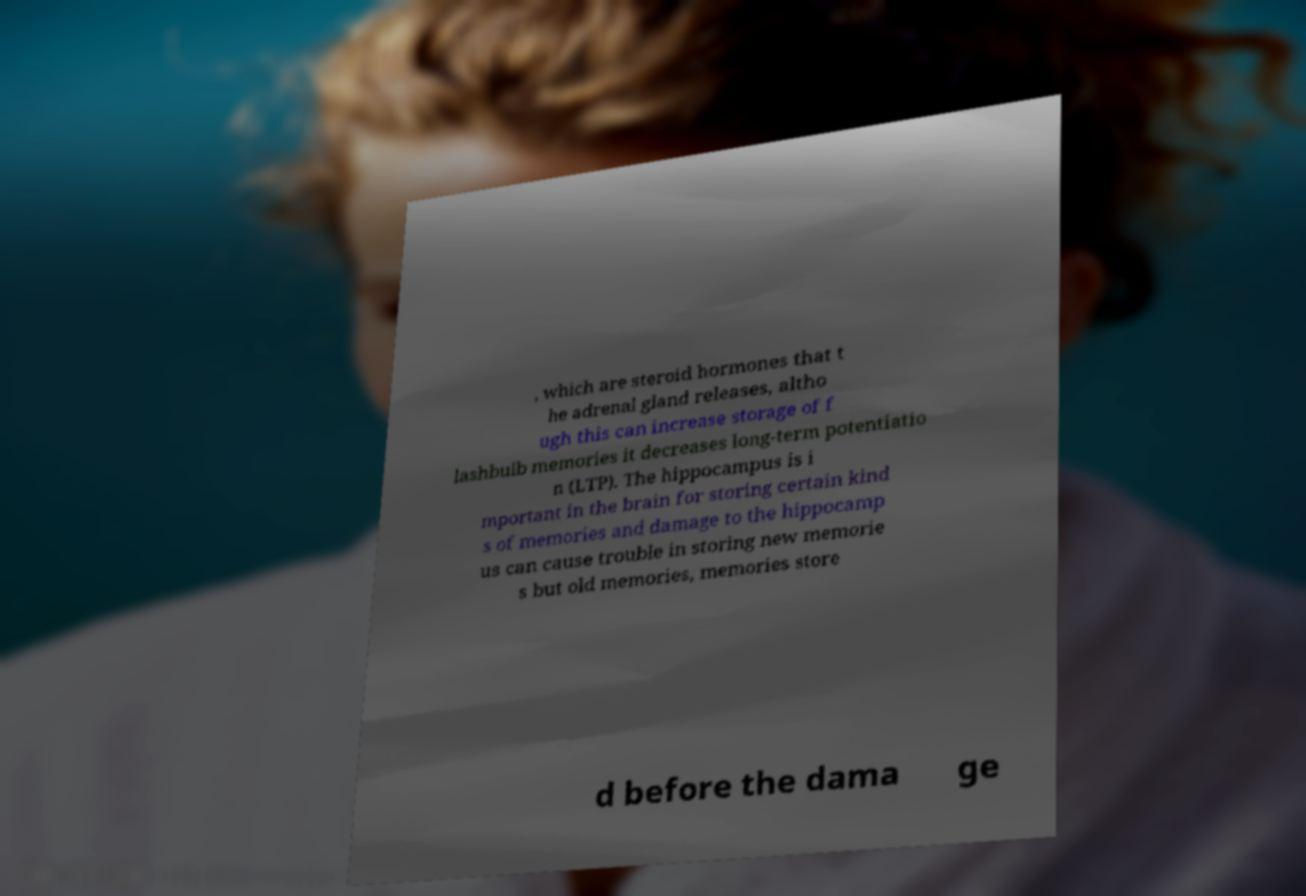For documentation purposes, I need the text within this image transcribed. Could you provide that? , which are steroid hormones that t he adrenal gland releases, altho ugh this can increase storage of f lashbulb memories it decreases long-term potentiatio n (LTP). The hippocampus is i mportant in the brain for storing certain kind s of memories and damage to the hippocamp us can cause trouble in storing new memorie s but old memories, memories store d before the dama ge 